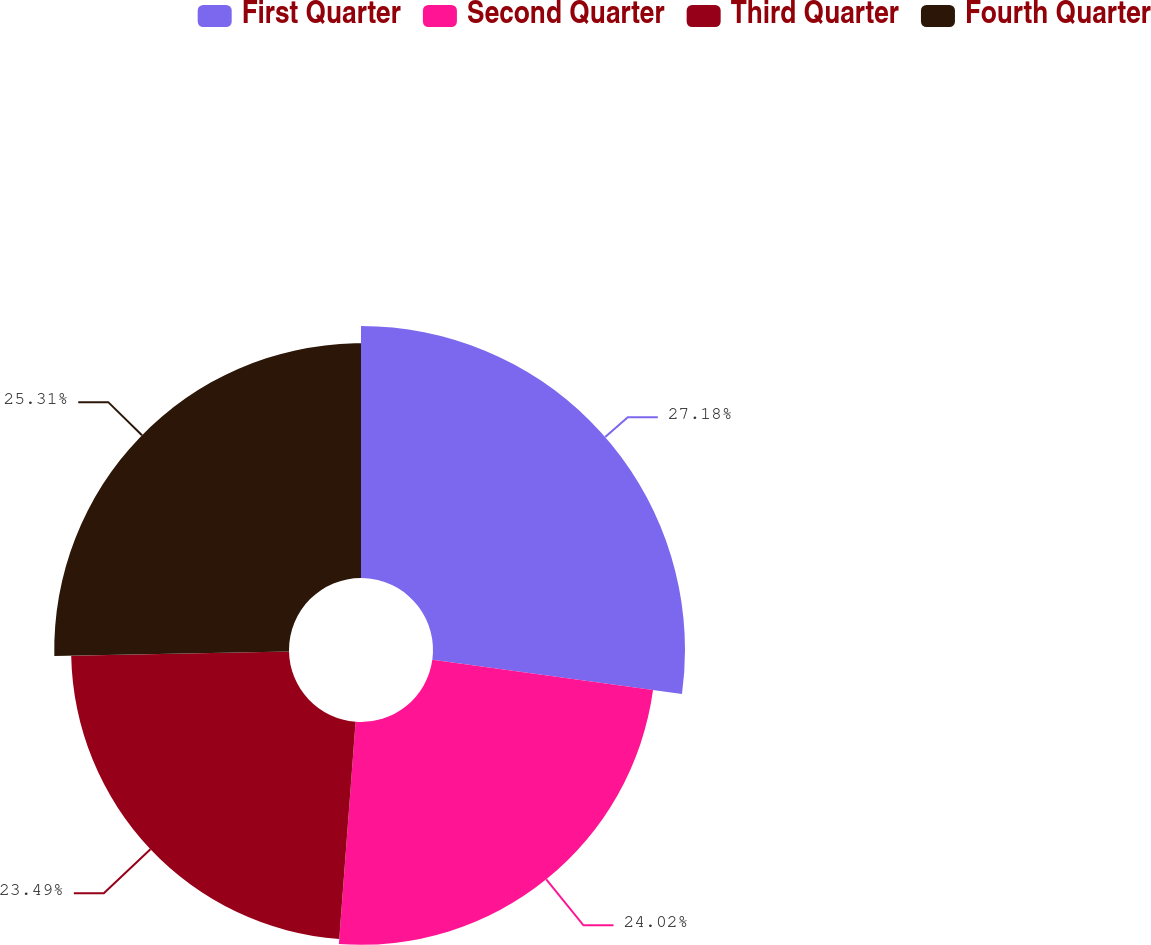Convert chart. <chart><loc_0><loc_0><loc_500><loc_500><pie_chart><fcel>First Quarter<fcel>Second Quarter<fcel>Third Quarter<fcel>Fourth Quarter<nl><fcel>27.17%<fcel>24.02%<fcel>23.49%<fcel>25.31%<nl></chart> 